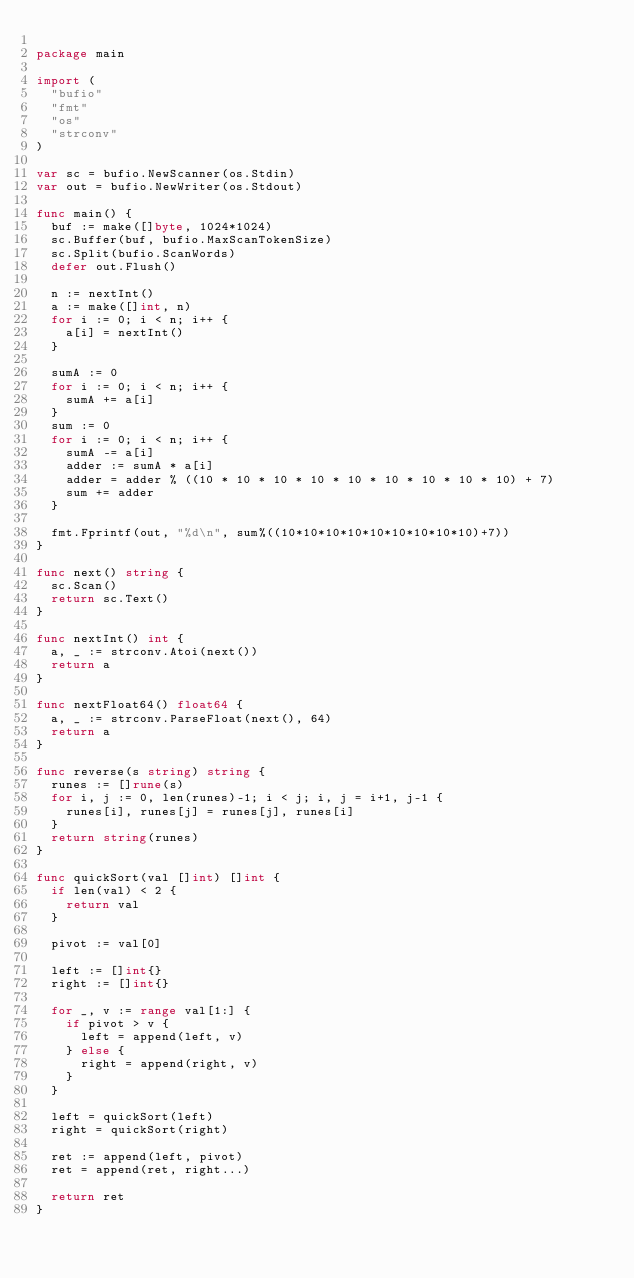Convert code to text. <code><loc_0><loc_0><loc_500><loc_500><_Go_>
package main

import (
	"bufio"
	"fmt"
	"os"
	"strconv"
)

var sc = bufio.NewScanner(os.Stdin)
var out = bufio.NewWriter(os.Stdout)

func main() {
	buf := make([]byte, 1024*1024)
	sc.Buffer(buf, bufio.MaxScanTokenSize)
	sc.Split(bufio.ScanWords)
	defer out.Flush()

	n := nextInt()
	a := make([]int, n)
	for i := 0; i < n; i++ {
		a[i] = nextInt()
	}

	sumA := 0
	for i := 0; i < n; i++ {
		sumA += a[i]
	}
	sum := 0
	for i := 0; i < n; i++ {
		sumA -= a[i]
		adder := sumA * a[i]
		adder = adder % ((10 * 10 * 10 * 10 * 10 * 10 * 10 * 10 * 10) + 7)
		sum += adder
	}

	fmt.Fprintf(out, "%d\n", sum%((10*10*10*10*10*10*10*10*10)+7))
}

func next() string {
	sc.Scan()
	return sc.Text()
}

func nextInt() int {
	a, _ := strconv.Atoi(next())
	return a
}

func nextFloat64() float64 {
	a, _ := strconv.ParseFloat(next(), 64)
	return a
}

func reverse(s string) string {
	runes := []rune(s)
	for i, j := 0, len(runes)-1; i < j; i, j = i+1, j-1 {
		runes[i], runes[j] = runes[j], runes[i]
	}
	return string(runes)
}

func quickSort(val []int) []int {
	if len(val) < 2 {
		return val
	}

	pivot := val[0]

	left := []int{}
	right := []int{}

	for _, v := range val[1:] {
		if pivot > v {
			left = append(left, v)
		} else {
			right = append(right, v)
		}
	}

	left = quickSort(left)
	right = quickSort(right)

	ret := append(left, pivot)
	ret = append(ret, right...)

	return ret
}
</code> 